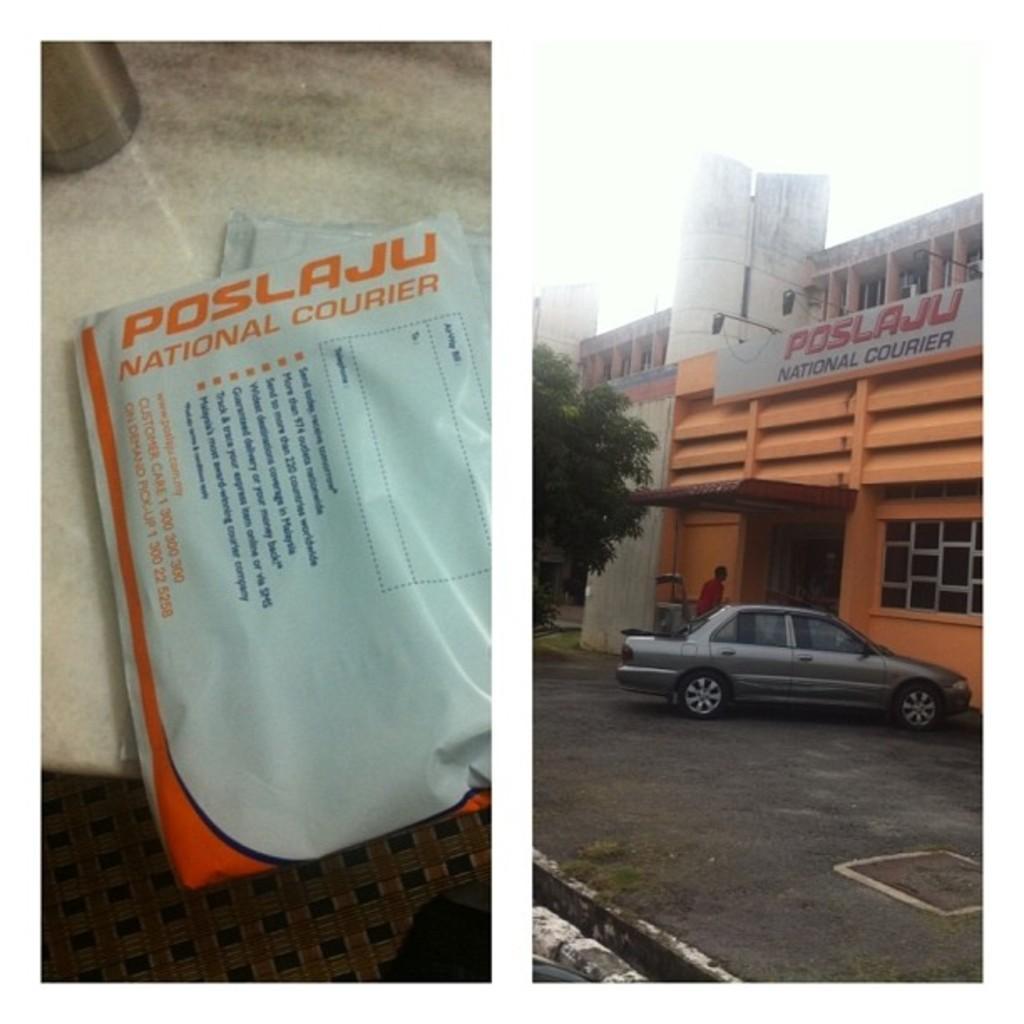Can you describe this image briefly? In this image I can see the collage picture in which I can see two blue colored packets on the white colored surface and a car which is grey in color on the road, a tree, a building which is orange and white in color, a board and in the background I can see the sky. 